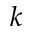<formula> <loc_0><loc_0><loc_500><loc_500>k</formula> 